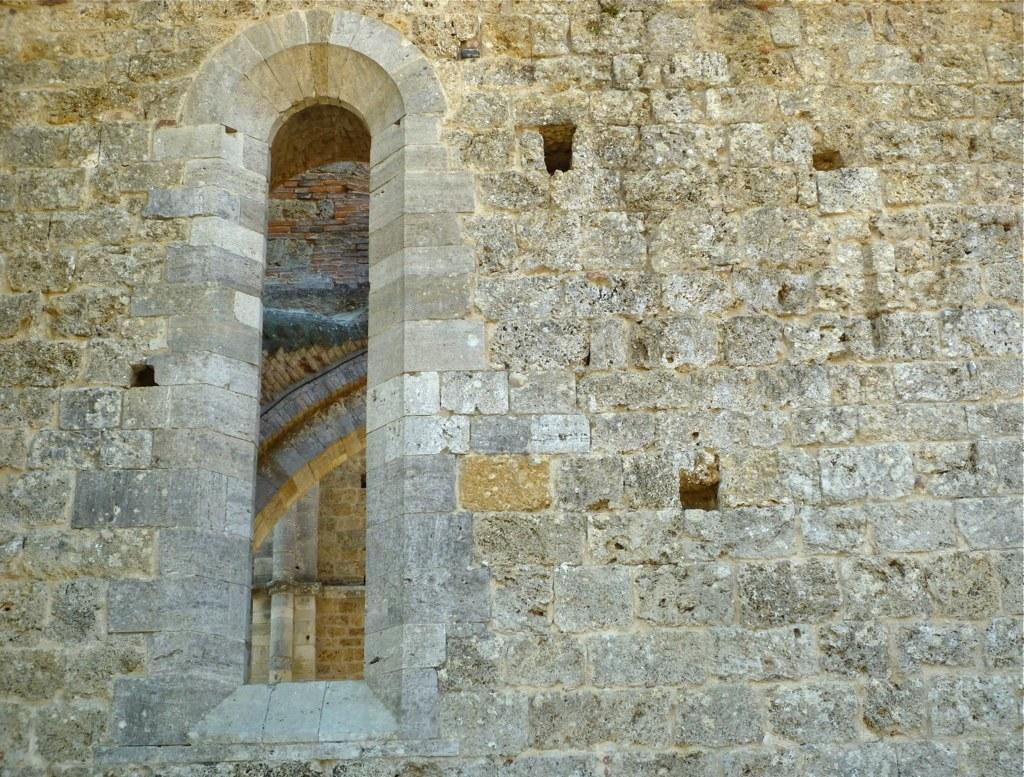What type of structure is visible in the image? There is a stone wall in the image. Are there any openings in the stone wall? Yes, the stone wall has a window. What can be seen through the window in the image? Through the window, we can see pillars. What type of bomb can be seen on the pillars in the image? There is no bomb present in the image; it features a stone wall with a window and pillars. What verse is written on the stone wall in the image? There is no verse written on the stone wall in the image; it is a solid structure with a window and pillars. 